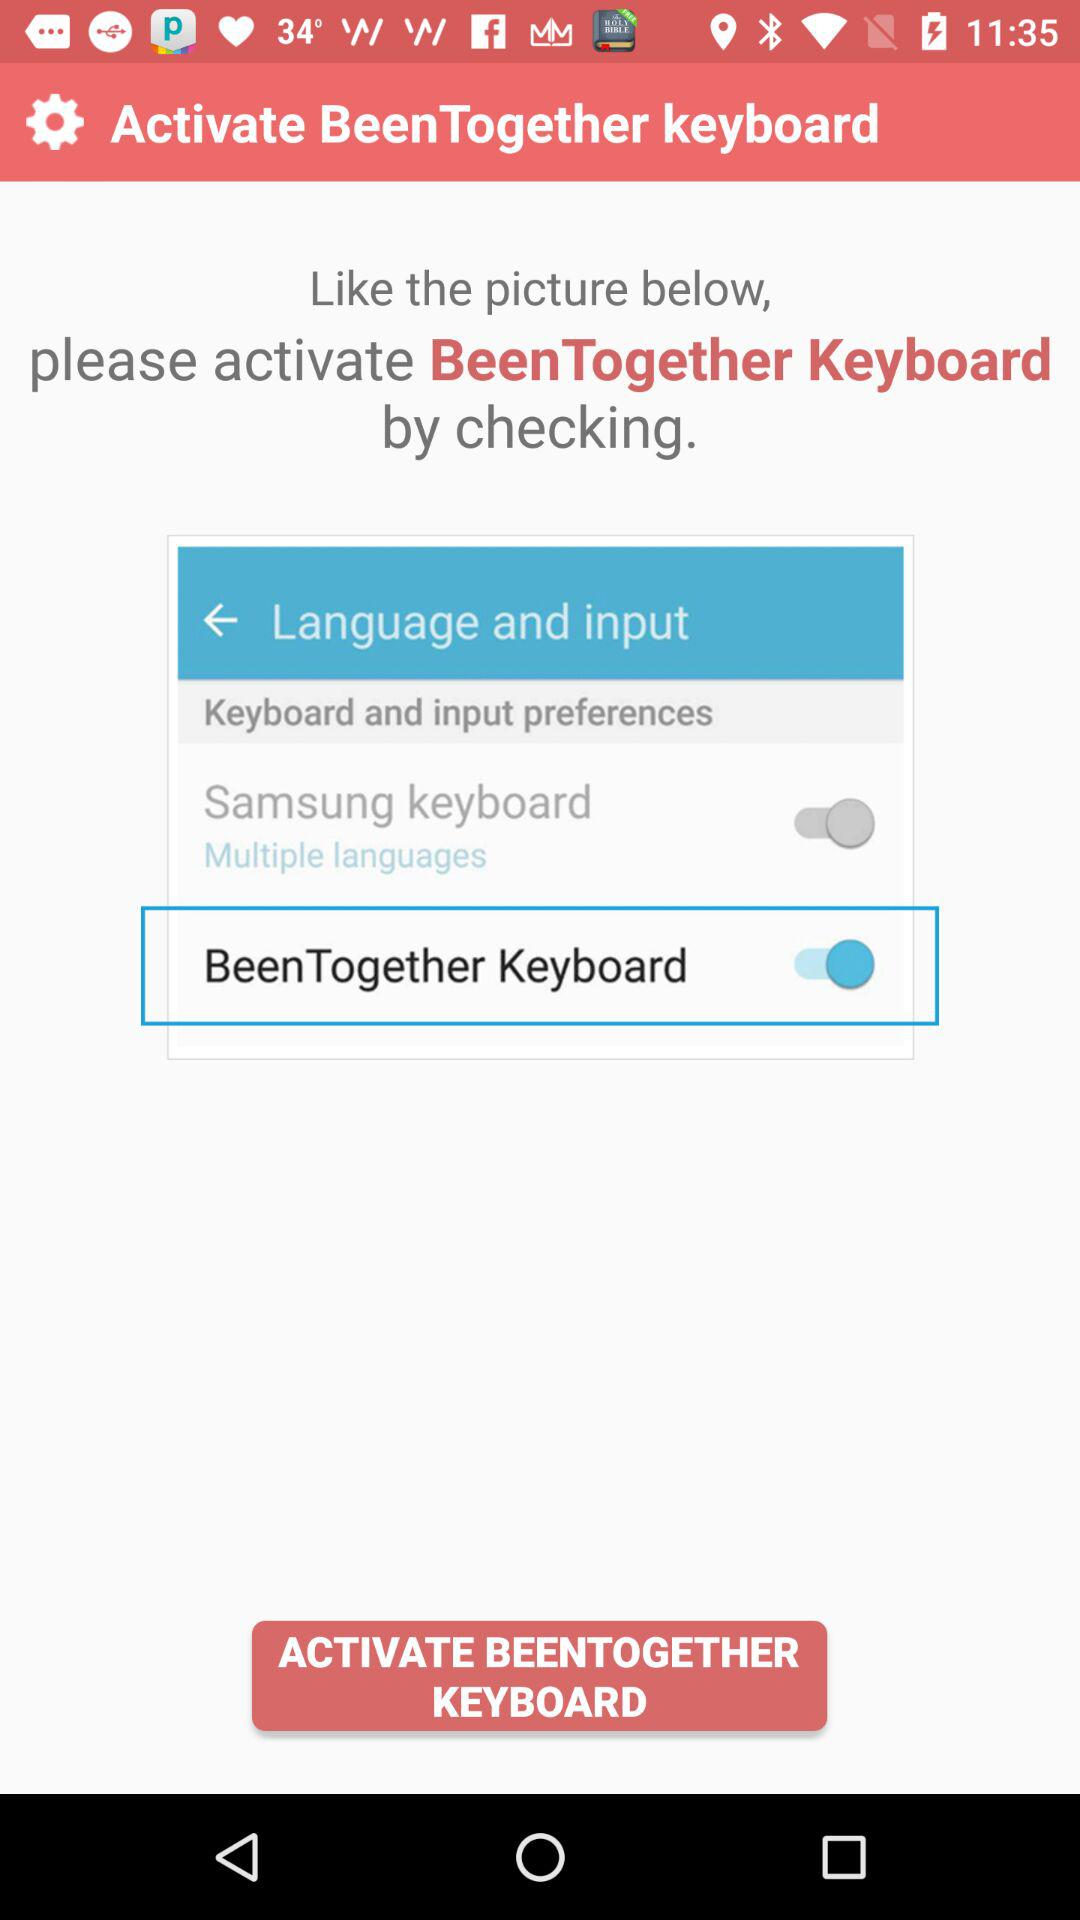What is the status of the "BeenTogether Keyboard"? The status is "on". 